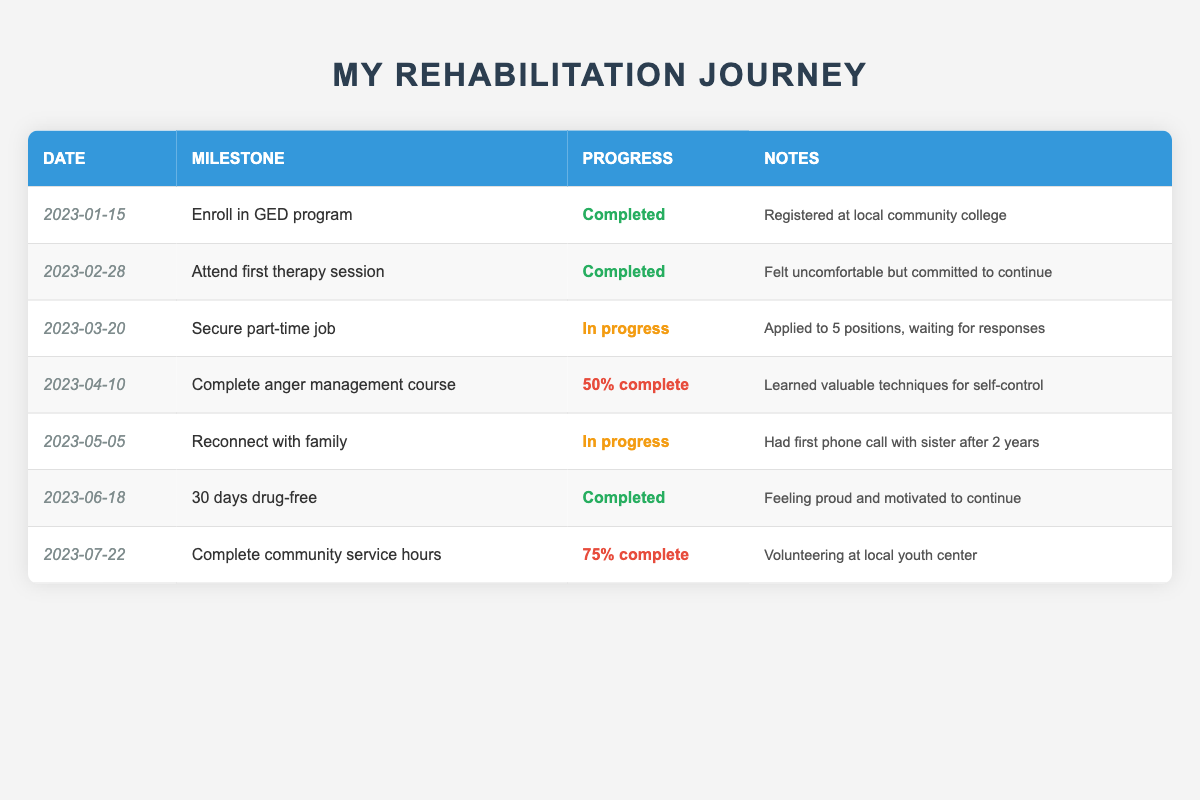What milestone was completed on January 15, 2023? The table shows that on January 15, 2023, the milestone "Enroll in GED program" was completed.
Answer: Enroll in GED program How many milestones are currently in progress? By examining the table, we see that there are two milestones marked as "In progress": "Secure part-time job" and "Reconnect with family."
Answer: 2 What percentage of the community service hours milestone is complete? The table indicates that the milestone "Complete community service hours" is "75% complete."
Answer: 75% complete True or False: The individual has attended three therapy sessions. The table only lists one milestone related to therapy, which is "Attend first therapy session," marked as completed. This indicates that they have only attended one session.
Answer: False What are the two most recent milestones completed? The two most recent milestones marked as "Completed" in the table are "30 days drug-free" on June 18, 2023, and "Attend first therapy session" on February 28, 2023.
Answer: 30 days drug-free; Attend first therapy session What is the time difference between the enrollment in the GED program and the completion of 30 days drug-free? The milestone "Enroll in GED program" was completed on January 15, 2023, and "30 days drug-free" on June 18, 2023. The time difference is 154 days.
Answer: 154 days How many milestones have been completed out of the total milestones listed? There are seven milestones total in the table, with four marked as "Completed": "Enroll in GED program," "Attend first therapy session," "30 days drug-free," and "Complete anger management course." Therefore, the total completed is 4 out of 7.
Answer: 4 out of 7 Which milestone has the earliest date and what does it signify? The earliest date in the table is January 15, 2023, for the milestone "Enroll in GED program." This signifies the beginning of the individual's educational rehabilitation journey.
Answer: Enroll in GED program What progress percentage has been achieved for the anger management course milestone? The table indicates that the anger management course milestone is "50% complete."
Answer: 50% complete 